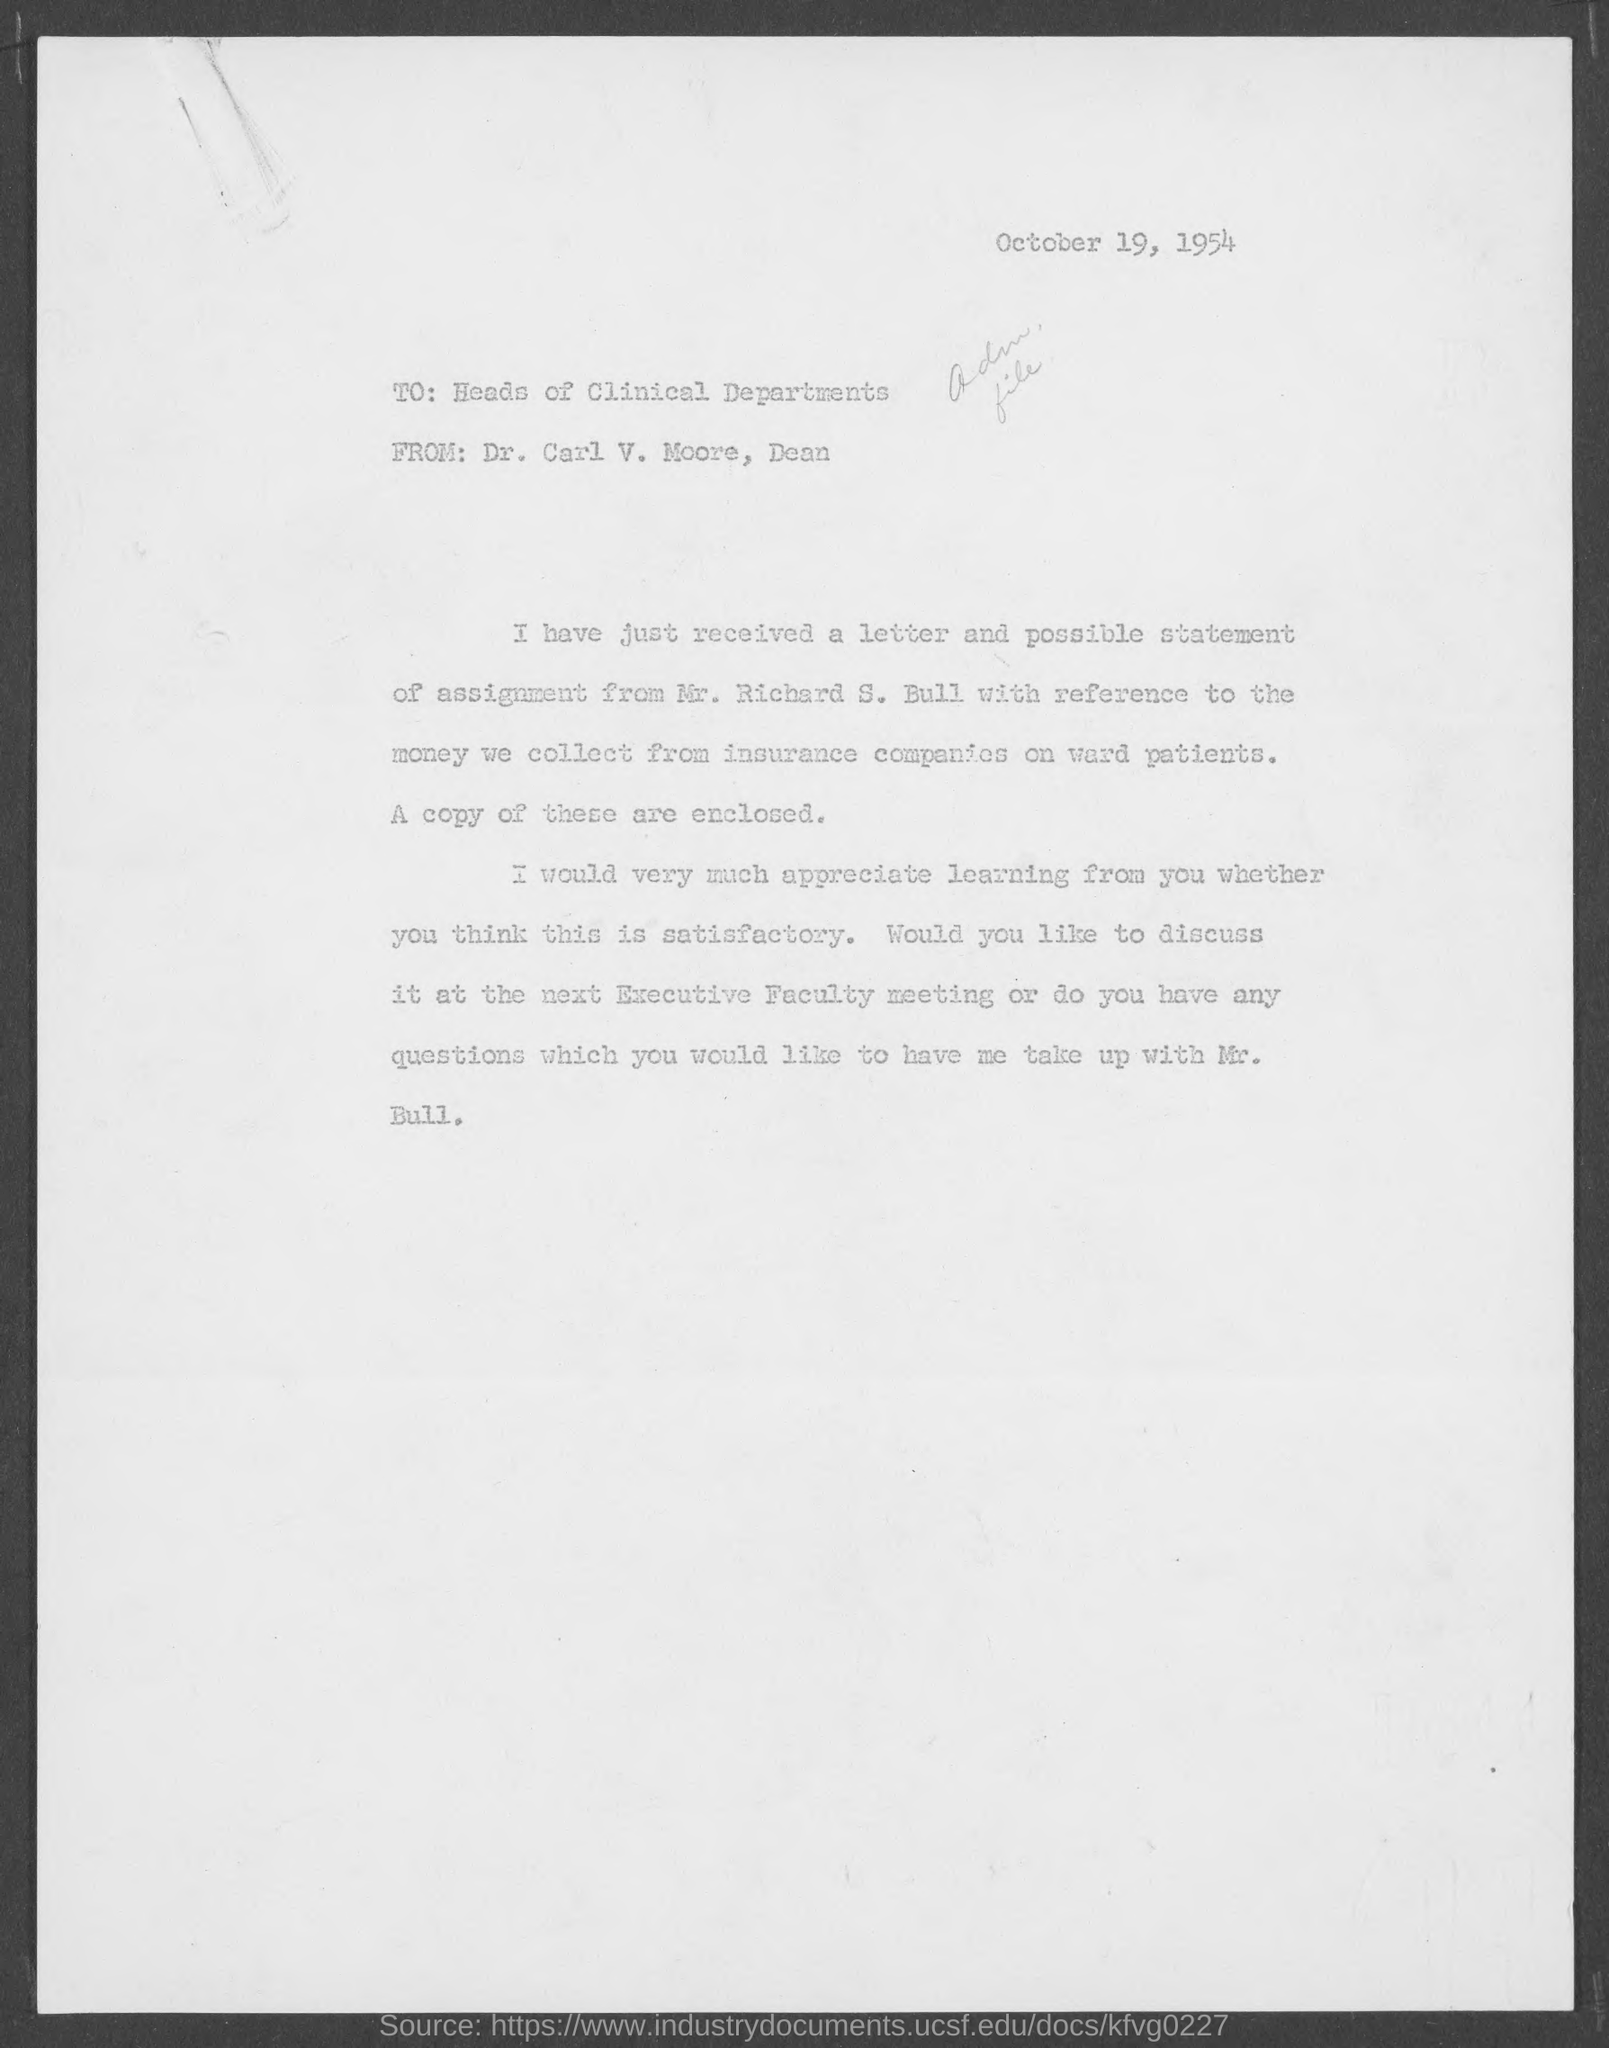When is letter dated?
Give a very brief answer. October 19, 1954. What is from address in letter ?
Provide a short and direct response. Dr. Carl V. Moore. What is the position of carl  v. moore?
Your answer should be compact. Dean. 